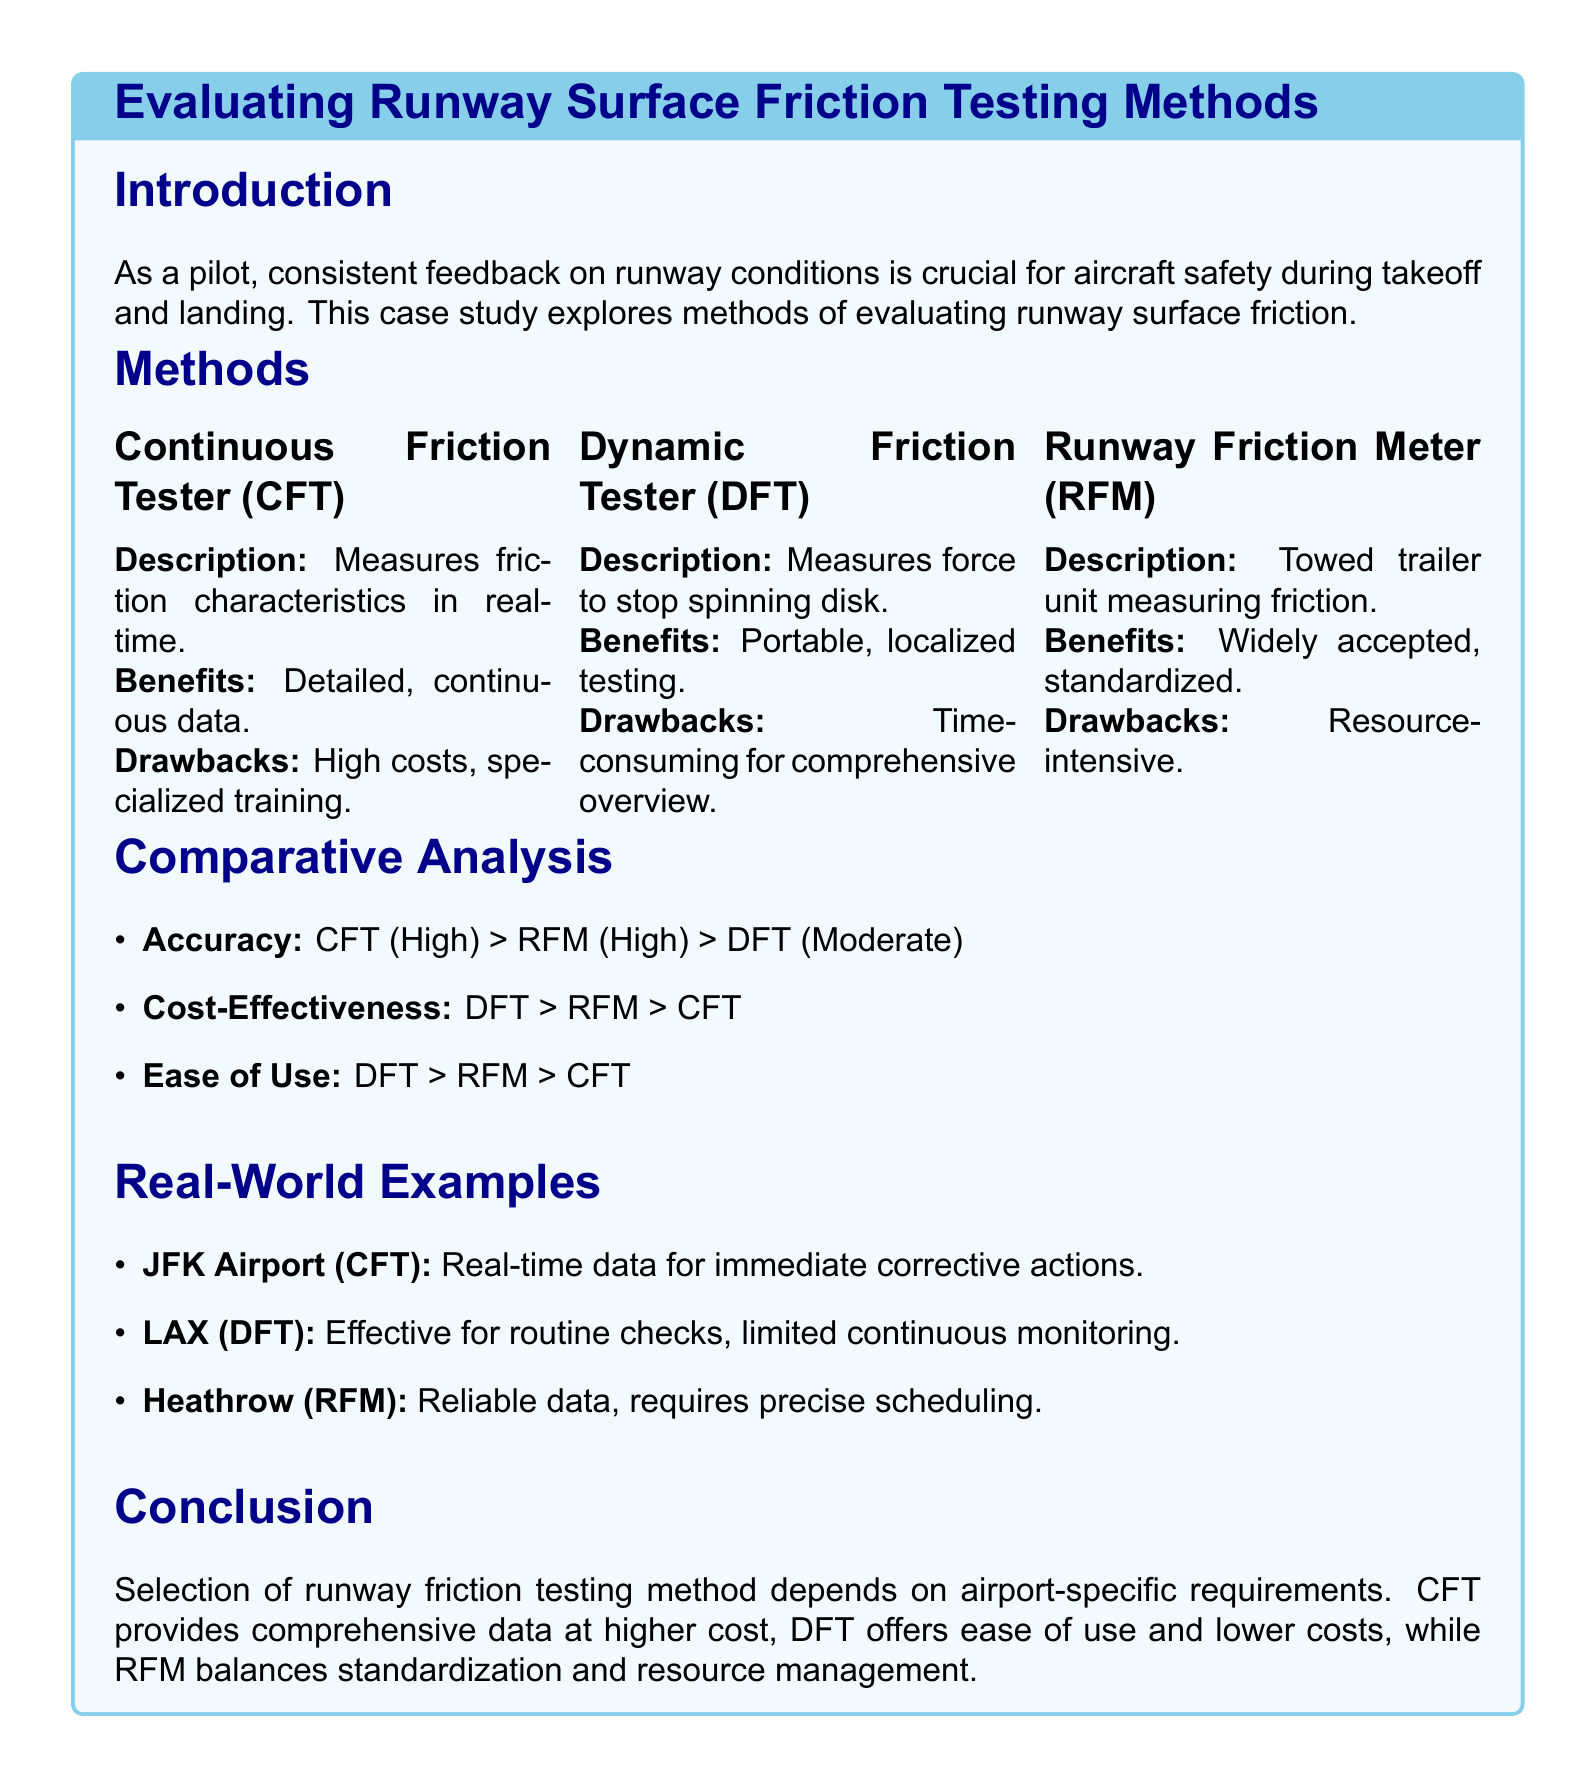What are the three runway surface friction testing methods mentioned? The document lists Continuous Friction Tester (CFT), Dynamic Friction Tester (DFT), and Runway Friction Meter (RFM) as the three methods.
Answer: CFT, DFT, RFM Which method offers real-time data? The Continuous Friction Tester (CFT) is described as providing real-time data for runway conditions.
Answer: CFT What is the rank in cost-effectiveness from most to least effective? The Comparative Analysis section indicates DFT is the most cost-effective, followed by RFM, and then CFT.
Answer: DFT, RFM, CFT Which runway testing method is widely accepted and standardized? The Runway Friction Meter (RFM) is noted for being widely accepted and standardized.
Answer: RFM At which airport was the CFT utilized for immediate corrective actions? The case study mentions JFK Airport as where the CFT was effectively used for immediate actions.
Answer: JFK Airport What is the primary drawback of the Dynamic Friction Tester (DFT)? The document states that the DFT is time-consuming for a comprehensive overview.
Answer: Time-consuming What does the conclusion suggest about the choice of testing method? The conclusion indicates that the choice of testing method depends on airport-specific requirements.
Answer: Airport-specific requirements Which runway friction testing method has moderate accuracy? The Dynamic Friction Tester (DFT) is categorized with moderate accuracy in the Comparative Analysis.
Answer: DFT 